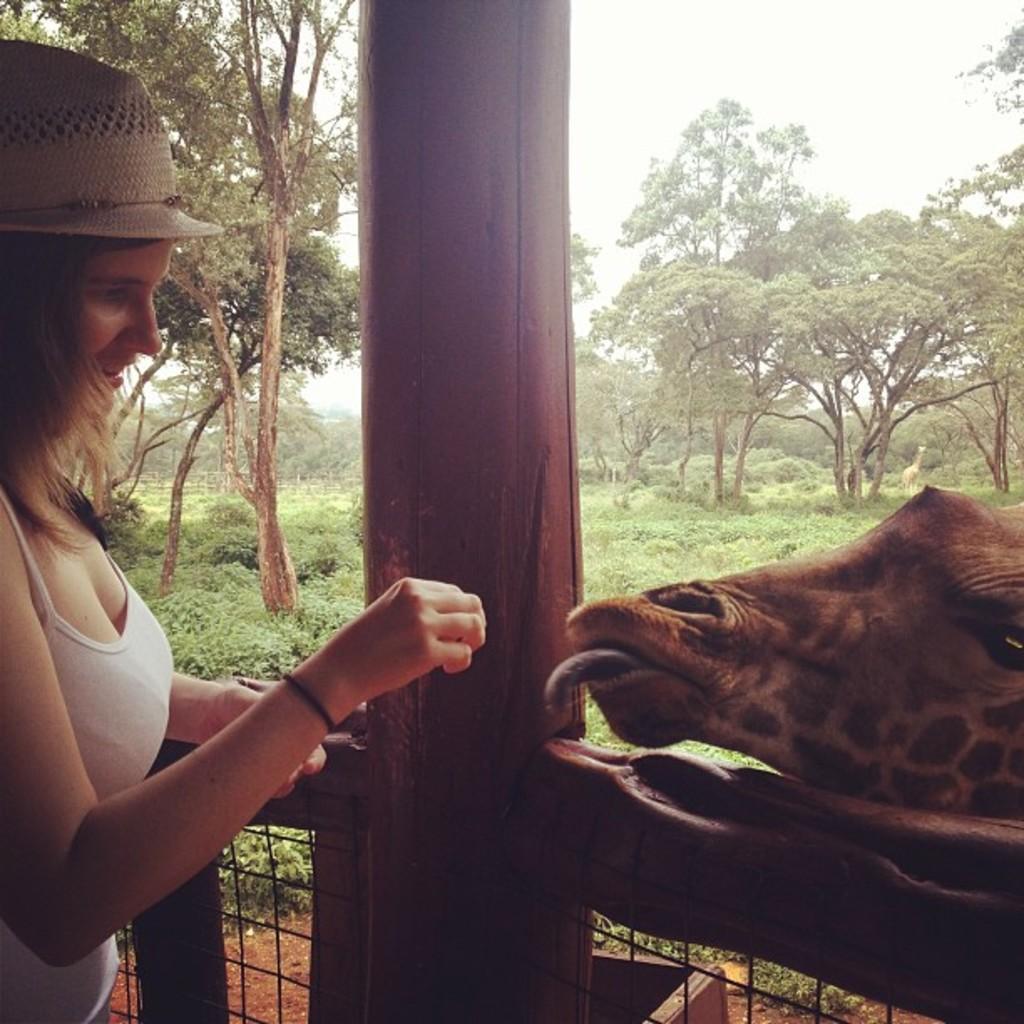In one or two sentences, can you explain what this image depicts? In this image we can see a person wearing white color top, brown color hat feeding some food to the giraffe which is at right side of the image and at the background of the image there are some trees, pole and clear sky. 